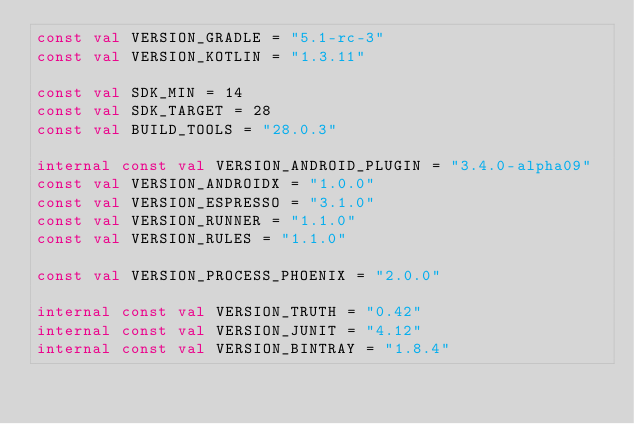<code> <loc_0><loc_0><loc_500><loc_500><_Kotlin_>const val VERSION_GRADLE = "5.1-rc-3"
const val VERSION_KOTLIN = "1.3.11"

const val SDK_MIN = 14
const val SDK_TARGET = 28
const val BUILD_TOOLS = "28.0.3"

internal const val VERSION_ANDROID_PLUGIN = "3.4.0-alpha09"
const val VERSION_ANDROIDX = "1.0.0"
const val VERSION_ESPRESSO = "3.1.0"
const val VERSION_RUNNER = "1.1.0"
const val VERSION_RULES = "1.1.0"

const val VERSION_PROCESS_PHOENIX = "2.0.0"

internal const val VERSION_TRUTH = "0.42"
internal const val VERSION_JUNIT = "4.12"
internal const val VERSION_BINTRAY = "1.8.4"</code> 